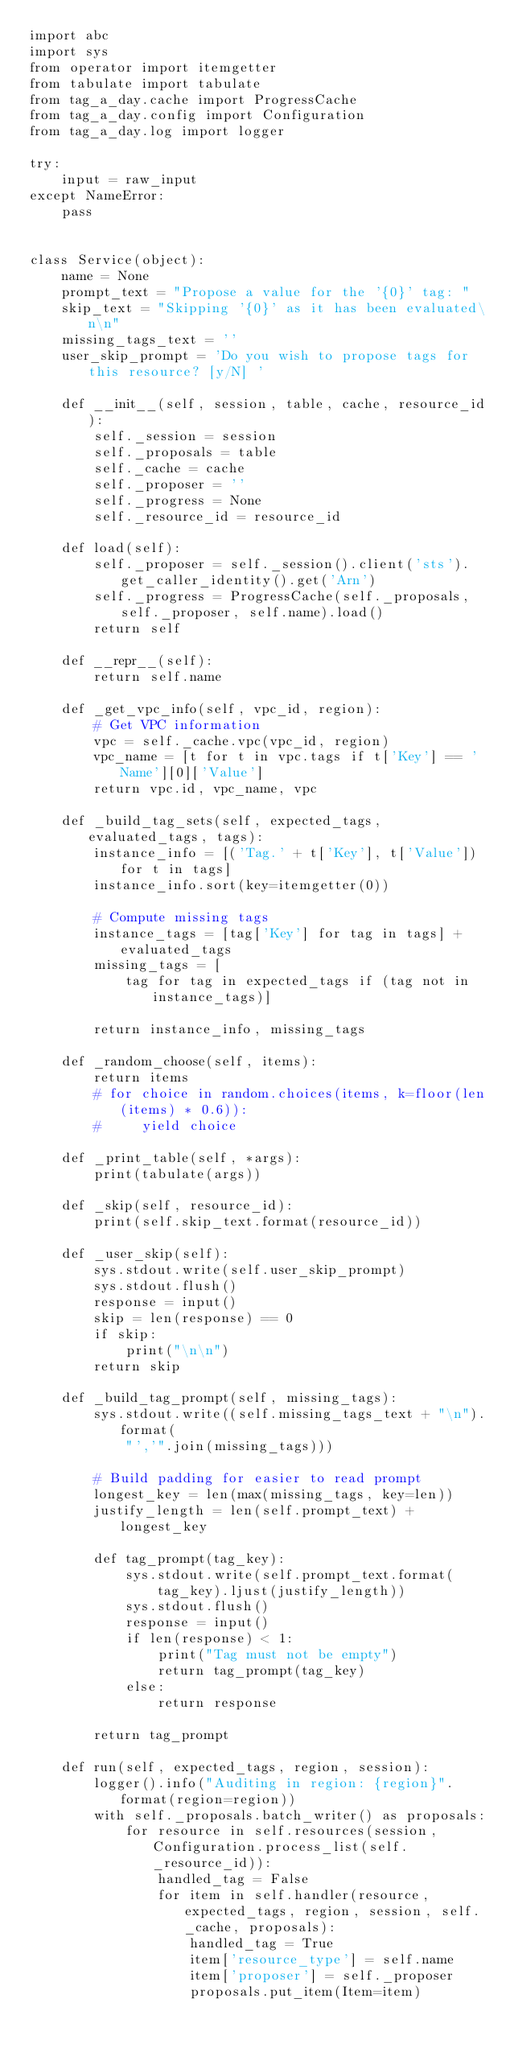<code> <loc_0><loc_0><loc_500><loc_500><_Python_>import abc
import sys
from operator import itemgetter
from tabulate import tabulate
from tag_a_day.cache import ProgressCache
from tag_a_day.config import Configuration
from tag_a_day.log import logger

try:
    input = raw_input
except NameError:
    pass


class Service(object):
    name = None
    prompt_text = "Propose a value for the '{0}' tag: "
    skip_text = "Skipping '{0}' as it has been evaluated\n\n"
    missing_tags_text = ''
    user_skip_prompt = 'Do you wish to propose tags for this resource? [y/N] '

    def __init__(self, session, table, cache, resource_id):
        self._session = session
        self._proposals = table
        self._cache = cache
        self._proposer = ''
        self._progress = None
        self._resource_id = resource_id

    def load(self):
        self._proposer = self._session().client('sts').get_caller_identity().get('Arn')
        self._progress = ProgressCache(self._proposals, self._proposer, self.name).load()
        return self

    def __repr__(self):
        return self.name

    def _get_vpc_info(self, vpc_id, region):
        # Get VPC information
        vpc = self._cache.vpc(vpc_id, region)
        vpc_name = [t for t in vpc.tags if t['Key'] == 'Name'][0]['Value']
        return vpc.id, vpc_name, vpc

    def _build_tag_sets(self, expected_tags, evaluated_tags, tags):
        instance_info = [('Tag.' + t['Key'], t['Value']) for t in tags]
        instance_info.sort(key=itemgetter(0))

        # Compute missing tags
        instance_tags = [tag['Key'] for tag in tags] + evaluated_tags
        missing_tags = [
            tag for tag in expected_tags if (tag not in instance_tags)]

        return instance_info, missing_tags

    def _random_choose(self, items):
        return items
        # for choice in random.choices(items, k=floor(len(items) * 0.6)):
        #     yield choice

    def _print_table(self, *args):
        print(tabulate(args))

    def _skip(self, resource_id):
        print(self.skip_text.format(resource_id))

    def _user_skip(self):
        sys.stdout.write(self.user_skip_prompt)
        sys.stdout.flush()
        response = input()
        skip = len(response) == 0
        if skip:
            print("\n\n")
        return skip

    def _build_tag_prompt(self, missing_tags):
        sys.stdout.write((self.missing_tags_text + "\n").format(
            "','".join(missing_tags)))

        # Build padding for easier to read prompt
        longest_key = len(max(missing_tags, key=len))
        justify_length = len(self.prompt_text) + longest_key

        def tag_prompt(tag_key):
            sys.stdout.write(self.prompt_text.format(
                tag_key).ljust(justify_length))
            sys.stdout.flush()
            response = input()
            if len(response) < 1:
                print("Tag must not be empty")
                return tag_prompt(tag_key)
            else:
                return response

        return tag_prompt

    def run(self, expected_tags, region, session):
        logger().info("Auditing in region: {region}".format(region=region))
        with self._proposals.batch_writer() as proposals:
            for resource in self.resources(session, Configuration.process_list(self._resource_id)):
                handled_tag = False
                for item in self.handler(resource, expected_tags, region, session, self._cache, proposals):
                    handled_tag = True
                    item['resource_type'] = self.name
                    item['proposer'] = self._proposer
                    proposals.put_item(Item=item)</code> 